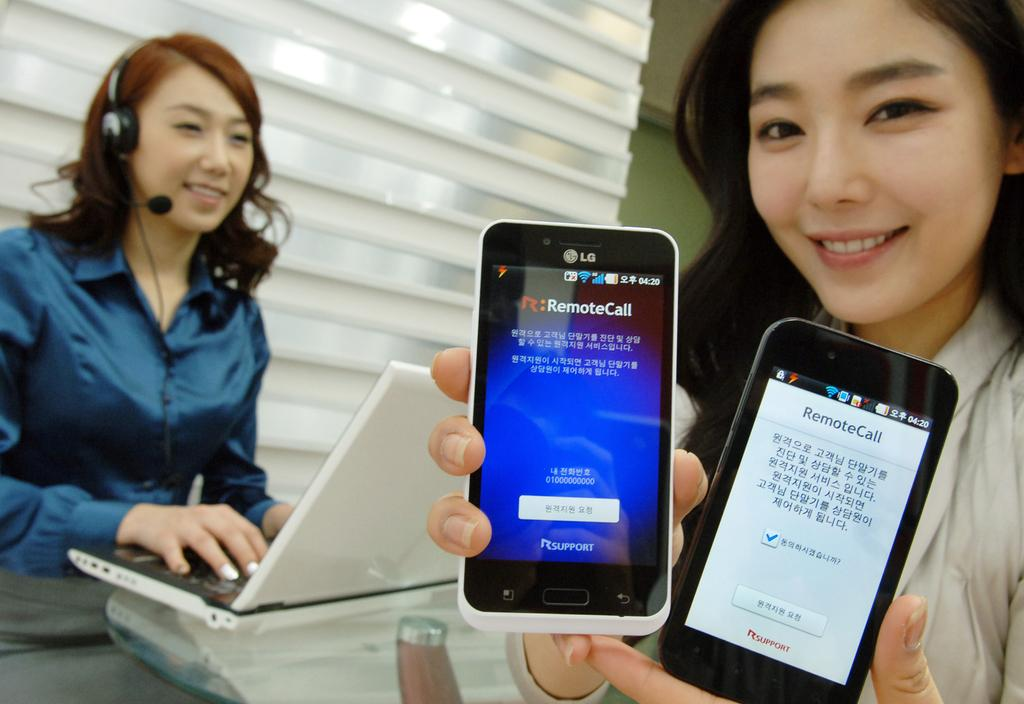How many ladies are present in the image? There are two ladies in the image. What is one of the ladies doing in the image? One of the ladies is working on a laptop. Can you describe the accessories the lady working on the laptop is wearing? The lady working on the laptop is wearing a headset. What is the other lady holding in the image? The other lady is holding two cell phones. What can be seen in the background of the image? There is a wall visible in the image. What is the source of the anger in the image? There is no indication of anger in the image; both ladies appear to be engaged in their respective tasks. Can you tell me how many cemeteries are visible in the image? There are no cemeteries present in the image. 